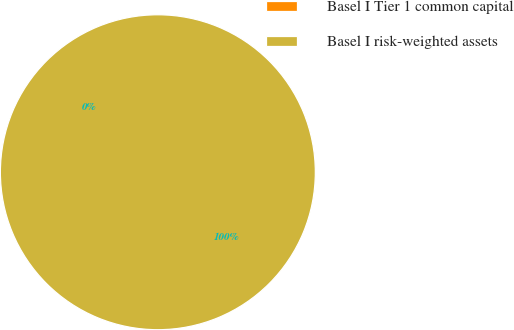Convert chart. <chart><loc_0><loc_0><loc_500><loc_500><pie_chart><fcel>Basel I Tier 1 common capital<fcel>Basel I risk-weighted assets<nl><fcel>0.0%<fcel>100.0%<nl></chart> 